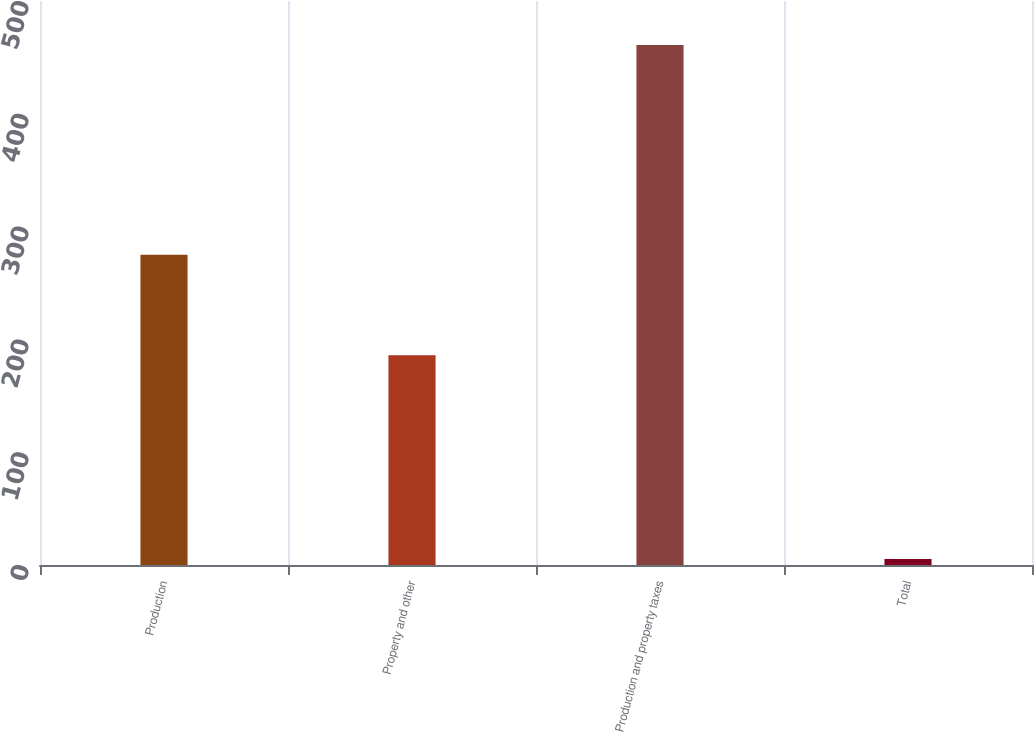Convert chart. <chart><loc_0><loc_0><loc_500><loc_500><bar_chart><fcel>Production<fcel>Property and other<fcel>Production and property taxes<fcel>Total<nl><fcel>275<fcel>186<fcel>461<fcel>5.4<nl></chart> 